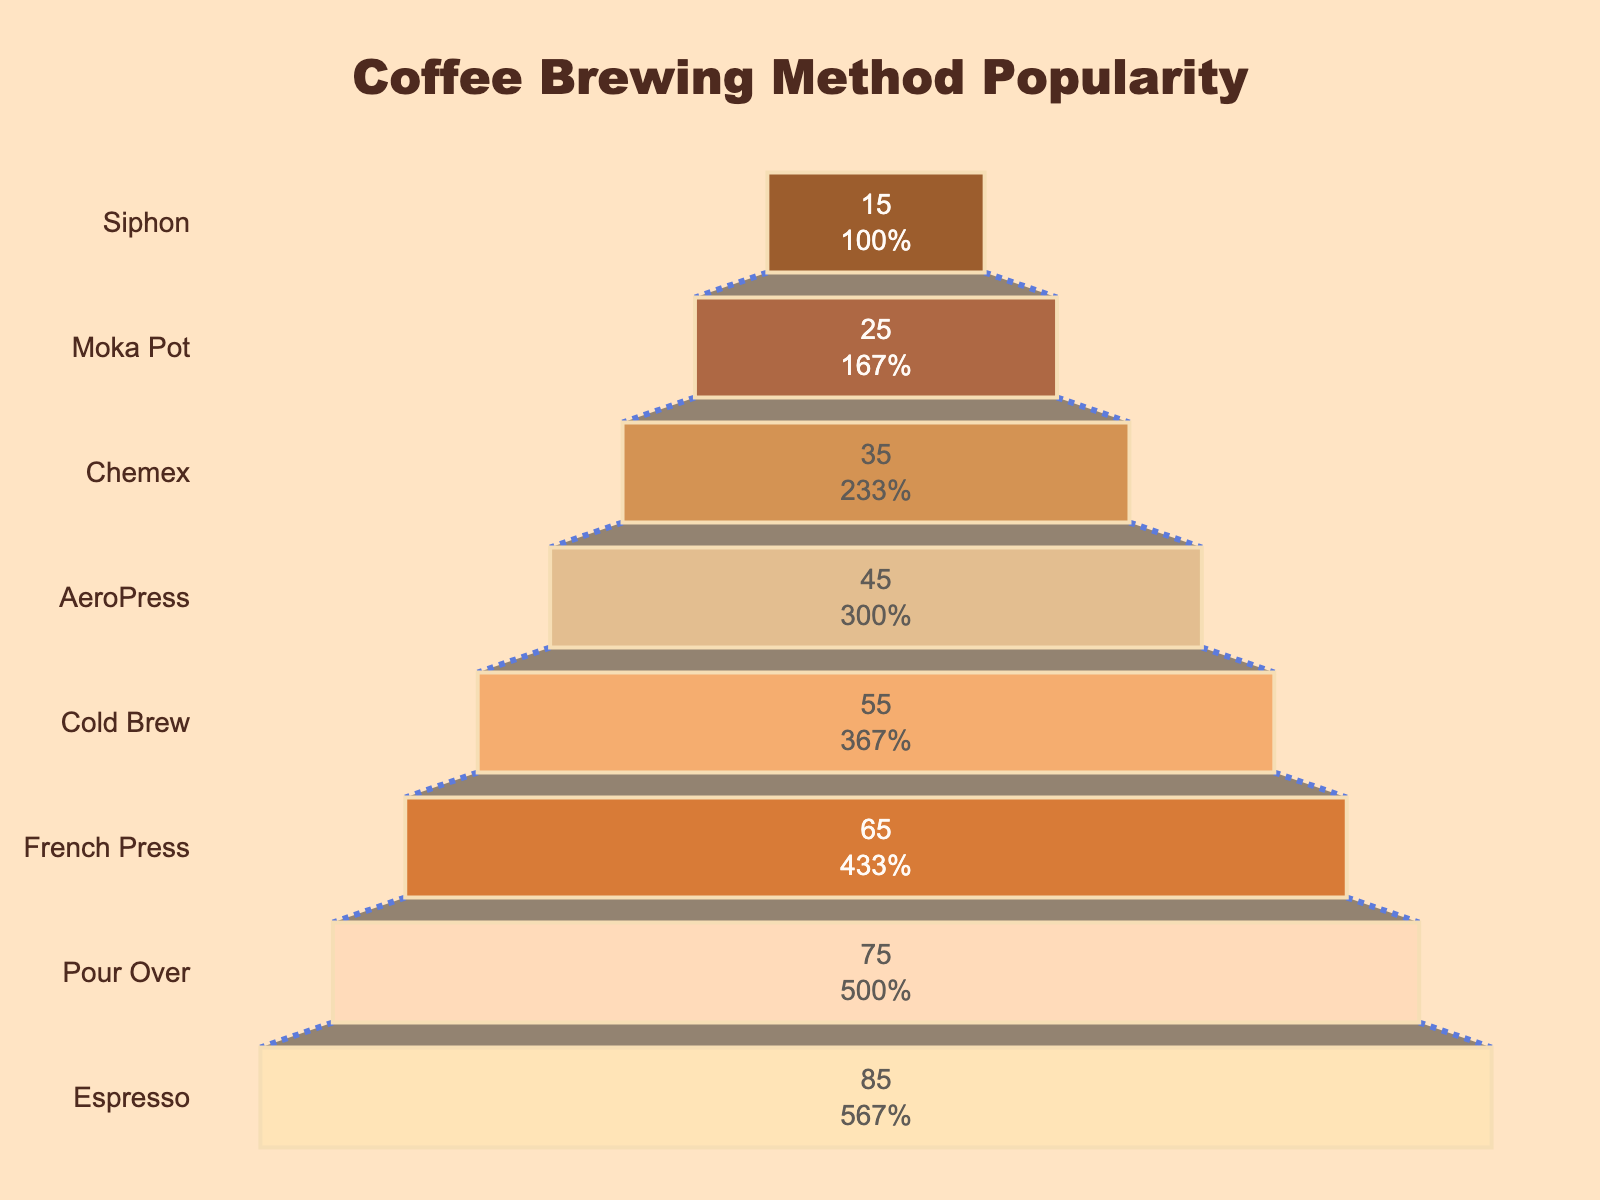What is the title of the funnel chart? The title is usually found at the top of the chart, centered. In this case, it reads "Coffee Brewing Method Popularity".
Answer: Coffee Brewing Method Popularity Which coffee brewing method is the most popular among enthusiasts? The most popular brewing method is represented by the largest section at the top of the funnel. Looking at the chart, the "Espresso" method is at the top with 85%.
Answer: Espresso How many different coffee brewing methods are represented in the figure? To find out the number of methods, count the distinct sections in the funnel chart. Each section represents a different method.
Answer: 8 What is the least popular coffee brewing method? The least popular brewing method is found at the bottom of the funnel chart. The method at the bottom is "Siphon" with 15%.
Answer: Siphon What is the total percentage of people who prefer either Espresso or Pour Over methods? Add the percentages of Espresso (85%) and Pour Over (75%) methods together. 85 + 75 = 160.
Answer: 160% What are the percentages of Cold Brew and AeroPress combined? Add the percentages of Cold Brew (55%) and AeroPress (45%) methods together. 55 + 45 = 100.
Answer: 100% Which method is more popular, French Press or Chemex, and by how much? Compare the percentages of French Press (65%) and Chemex (35%). The difference is 65 - 35 = 30.
Answer: French Press by 30% What does the annotation at the bottom of the funnel chart say? The annotation is a text added to the chart, usually found at the bottom. Here it states, "Coffee is the superior beverage!".
Answer: Coffee is the superior beverage! How is the visual difference between the markers of each section represented? The markers for each section vary in color from darker to lighter shades of brown as you go down the funnel, representing different coffee-related colors. Each section also has a border around it for distinction.
Answer: Color variation and borders What percentage of the methods have a popularity above 50%? Count the methods with percentages above 50%. Espresso (85%), Pour Over (75%), French Press (65%), and Cold Brew (55%) all fit this criterion. So, 4 out of 8 methods.
Answer: 50% 